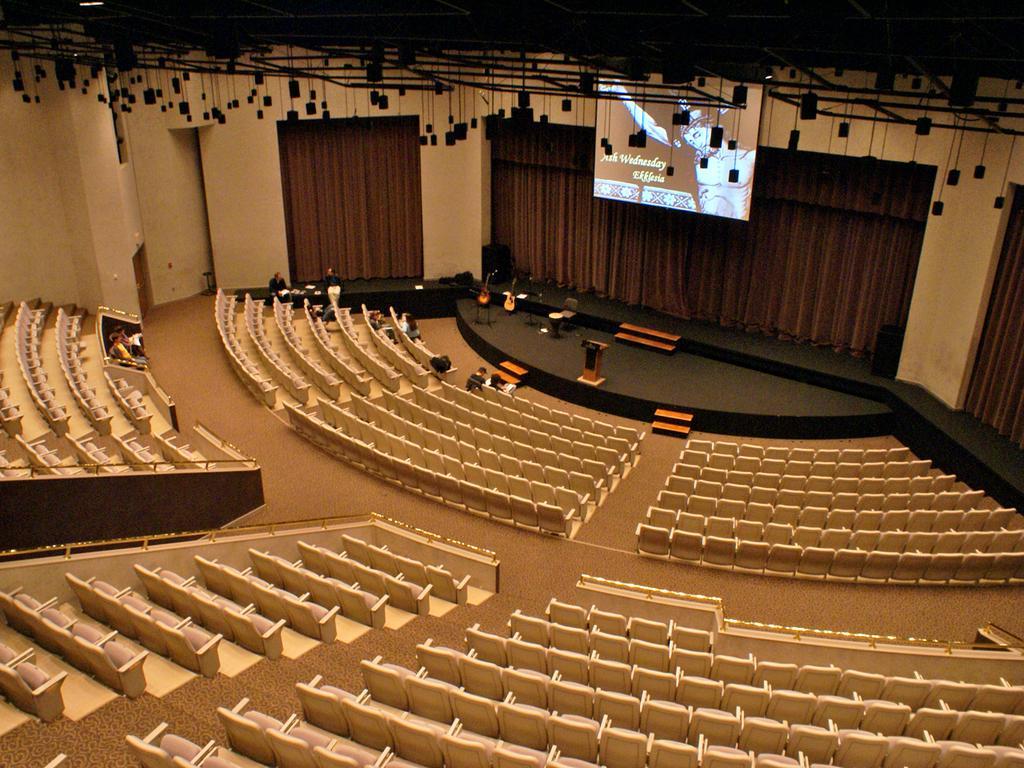In one or two sentences, can you explain what this image depicts? This is the picture of an auditorium. On the left side of the image there are two persons sitting on the chairs. At the back there are group of people sitting on the chairs. There are two persons sitting behind the table and there are objects on the table. There are musical instruments and there is a podium on the stage. At the back there are curtains. At the top there is a screen. 